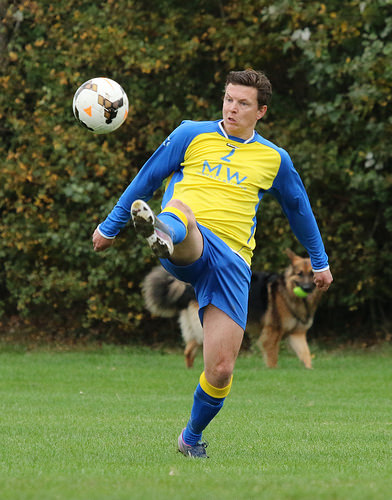<image>
Can you confirm if the man is behind the dog? No. The man is not behind the dog. From this viewpoint, the man appears to be positioned elsewhere in the scene. Is the dog next to the man? No. The dog is not positioned next to the man. They are located in different areas of the scene. Is the man in front of the dog? Yes. The man is positioned in front of the dog, appearing closer to the camera viewpoint. 